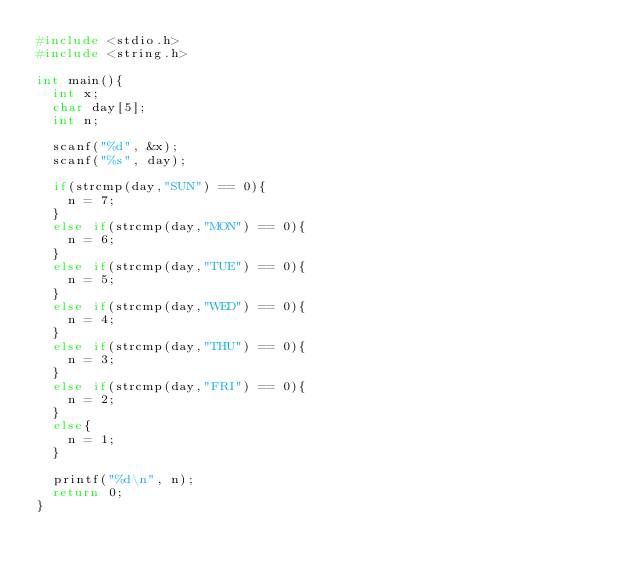<code> <loc_0><loc_0><loc_500><loc_500><_C_>#include <stdio.h>
#include <string.h>

int main(){
  int x;
  char day[5];
  int n;

  scanf("%d", &x);
  scanf("%s", day);

  if(strcmp(day,"SUN") == 0){
    n = 7;
  }
  else if(strcmp(day,"MON") == 0){
    n = 6;
  }
  else if(strcmp(day,"TUE") == 0){
    n = 5;
  }
  else if(strcmp(day,"WED") == 0){
    n = 4;
  }
  else if(strcmp(day,"THU") == 0){
    n = 3;
  }
  else if(strcmp(day,"FRI") == 0){
    n = 2;
  }
  else{
    n = 1;
  }

  printf("%d\n", n);
  return 0;
}
</code> 